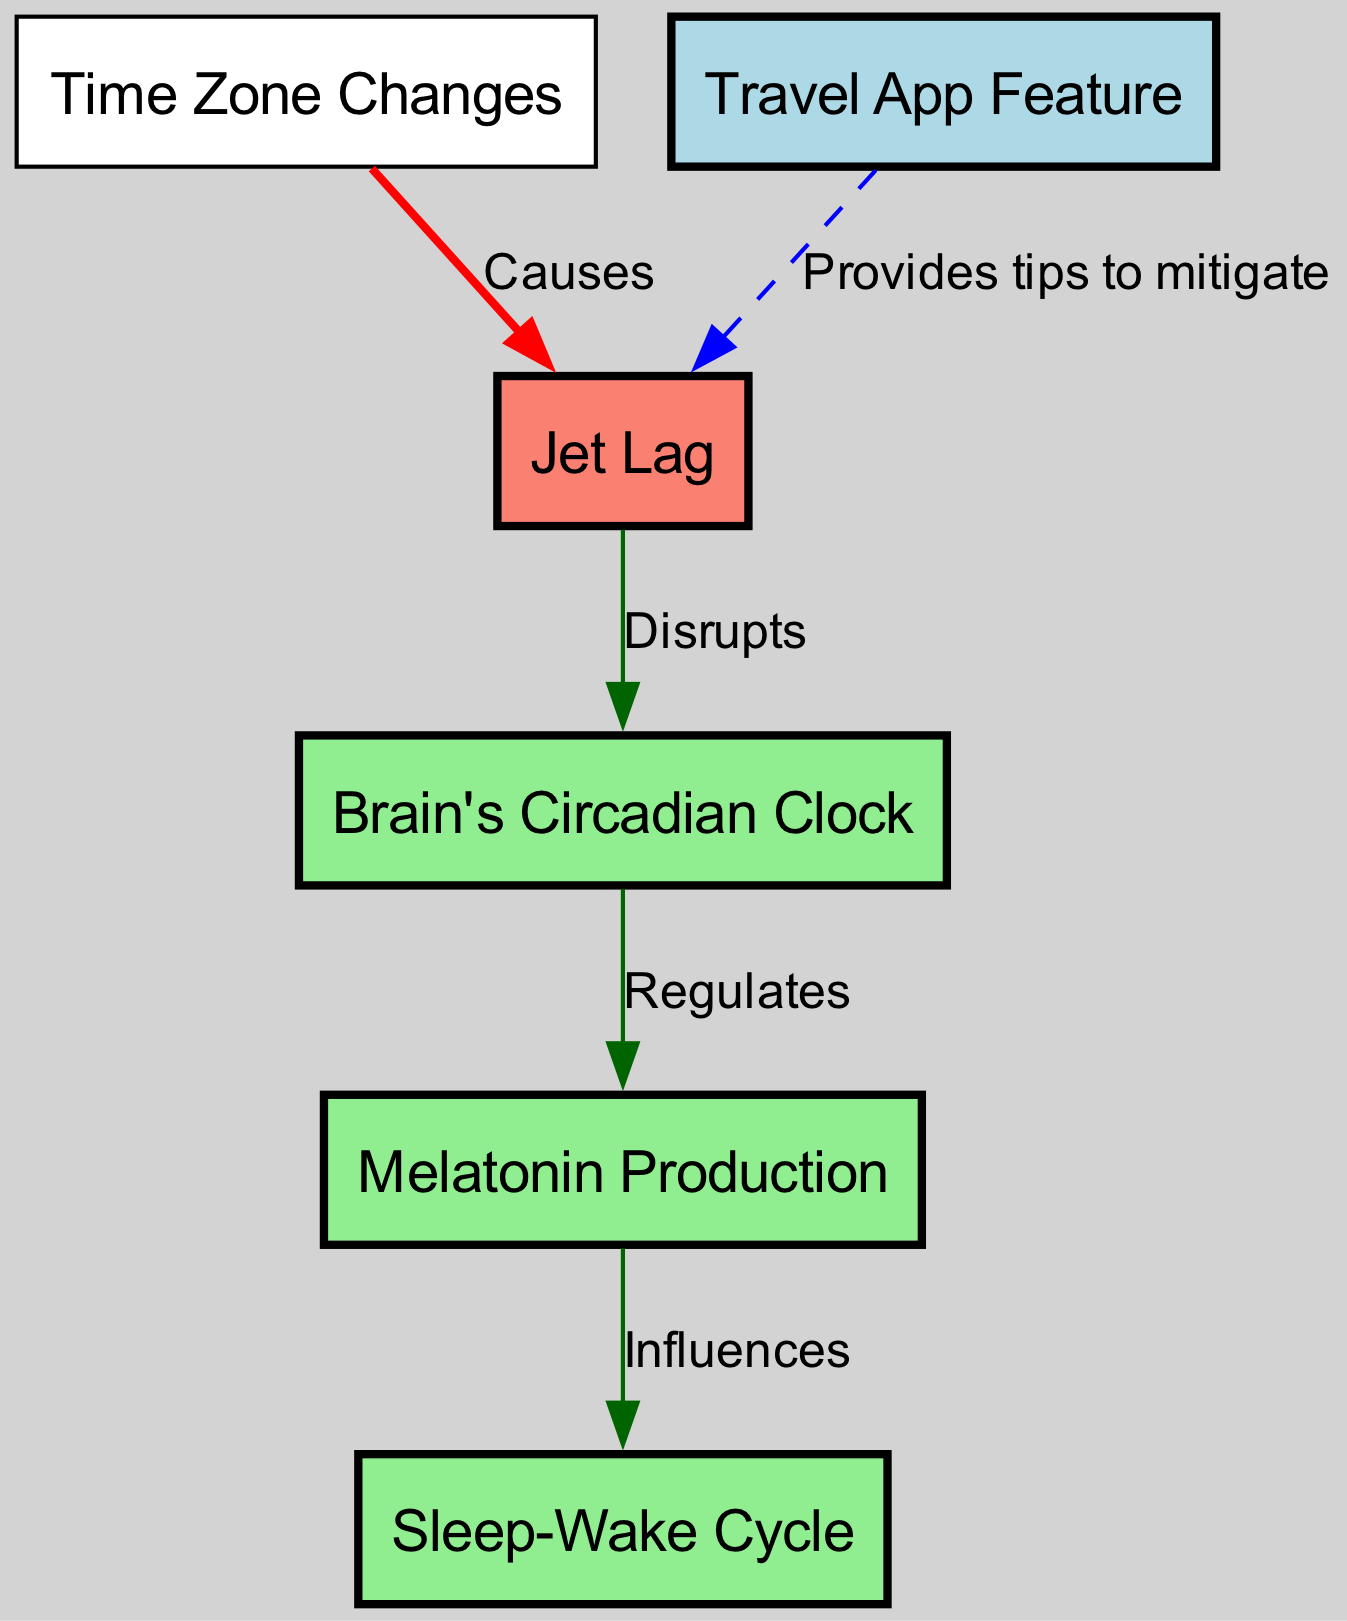What causes jet lag? The diagram states that jet lag is caused by time zone changes, as indicated by the directed edge labeling "Causes" from time zones to jet lag.
Answer: Time Zone Changes How many edges are in the diagram? By counting the connections (arrows) shown in the diagram, we find there are five edges representing relationships between the nodes.
Answer: 5 What influence does melatonin have? According to the diagram, melatonin influences the sleep-wake cycle, as shown by the directed edge with the label "Influences" connecting melatonin to sleep cycle.
Answer: Sleep-Wake Cycle What does the travel app feature provide regarding jet lag? The diagram indicates that the travel app provides tips to mitigate jet lag, which is shown by the dashed edge from travel app to jet lag labeled "Provides tips to mitigate."
Answer: Tips to mitigate How does jet lag affect the circadian clock? Jet lag disrupts the brain's circadian clock, as shown by the directed edge from jet lag to circadian clock labeled "Disrupts."
Answer: Disrupts Which node is identified as brain's circadian clock in the diagram? The node labeled "Brain's Circadian Clock" represents the brain's circadian clock directly as identified in the diagram.
Answer: Brain's Circadian Clock What regulates the production of melatonin? The diagram shows that the brain's circadian clock regulates melatonin production, indicated by the directed edge from circadian clock to melatonin labeled "Regulates."
Answer: Regulates What color represents jet lag in the diagram? The color used to represent jet lag in the diagram is salmon, as indicated through the coloring scheme described for the nodes.
Answer: Salmon How many nodes represent biological elements in the diagram? There are three nodes representing biological elements: circadian clock, melatonin, and sleep cycle, identified by their respective labels within the diagram.
Answer: 3 